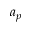Convert formula to latex. <formula><loc_0><loc_0><loc_500><loc_500>a _ { p }</formula> 